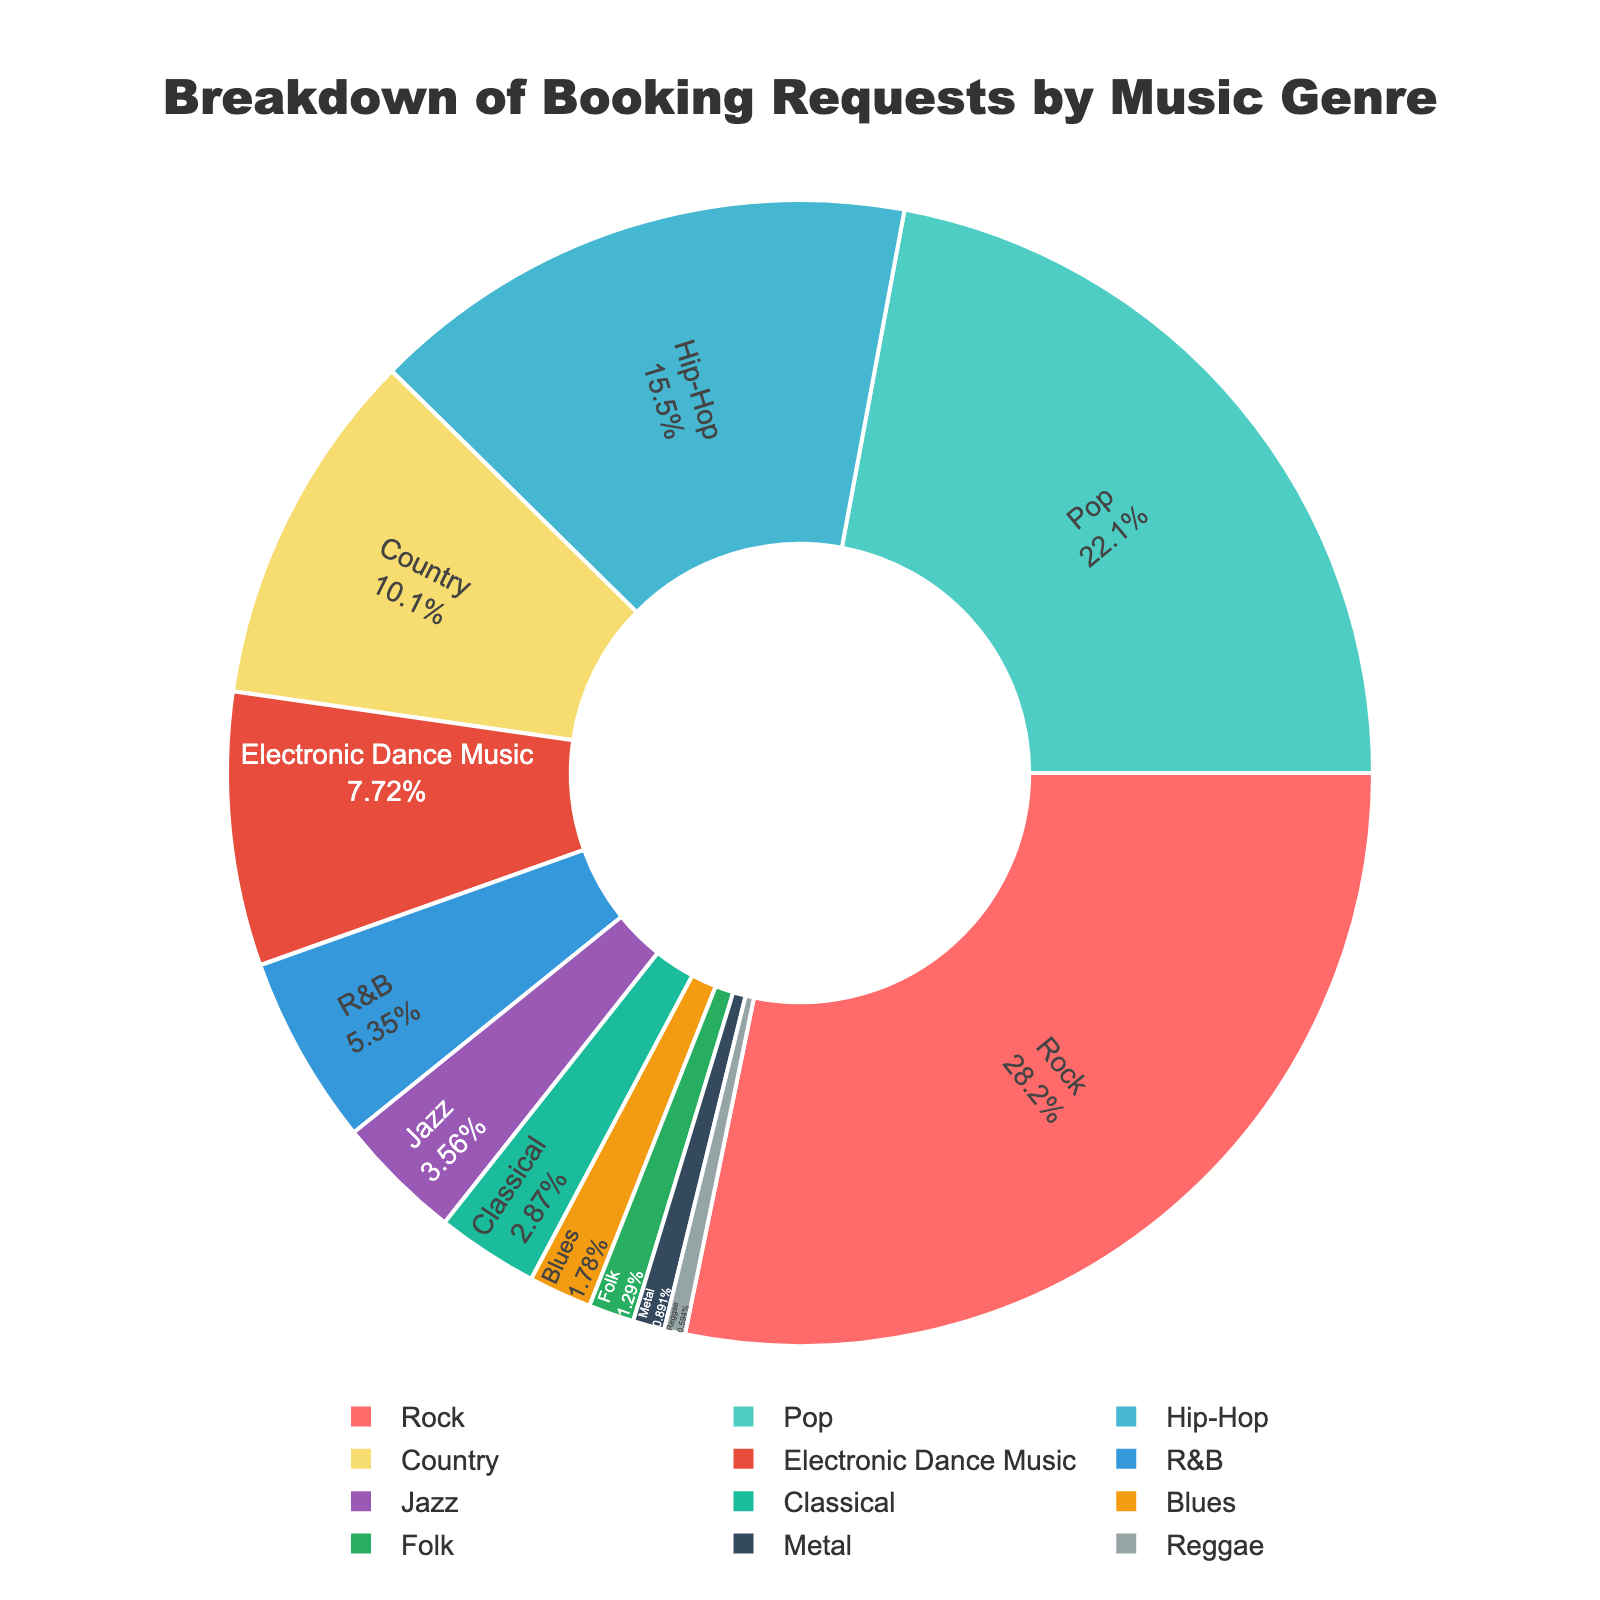Which genre has the highest percentage of booking requests? The figure shows that Rock has the largest segment in the pie chart. The percentage given for Rock is 28.5% which is the highest among all genres.
Answer: Rock Which two genres combined constitute over 50% of the booking requests? Adding the percentages for Rock and Pop, Rock (28.5%) + Pop (22.3%) = 50.8%. Thus, Rock and Pop combined make up over 50% of the booking requests.
Answer: Rock and Pop What's the percentage difference between Rock and Country? Subtract the percentage of Country from Rock. Rock (28.5%) - Country (10.2%) = 18.3%.
Answer: 18.3% Which genre has a lower booking percentage, Jazz or Classical? The chart shows that Jazz has 3.6% and Classical has 2.9%. Since 2.9% is less than 3.6%, Classical has a lower booking percentage.
Answer: Classical What is the combined percentage of the three least popular genres? Adding the percentages of the three least popular genres: Metal (0.9%) + Reggae (0.6%) + Folk (1.3%) = 2.8%.
Answer: 2.8% Which genre occupies the third largest segment in the pie chart? The pie chart displays that the third largest segment belongs to Hip-Hop with 15.7%.
Answer: Hip-Hop How much more popular is Pop compared to Electronic Dance Music (EDM)? Subtract the percentage of EDM from the percentage of Pop. Pop (22.3%) - EDM (7.8%) = 14.5%.
Answer: 14.5% Is Country more or less popular than Hip-Hop? The chart indicates that Country has a booking percentage of 10.2% while Hip-Hop has 15.7%. Since 15.7% > 10.2%, Country is less popular than Hip-Hop.
Answer: Less What is the average booking percentage of Jazz, Classical, and Blues? Add the percentages for Jazz (3.6%), Classical (2.9%), and Blues (1.8%) and divide by 3. (3.6 + 2.9 + 1.8) / 3 = 2.7667 rounded to 2.8%.
Answer: 2.8% Which genre has bookings closest to 5%? The genre with bookings closest to 5% is R&B with a booking percentage of 5.4%, which is the closest to 5%.
Answer: R&B 